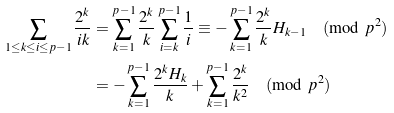<formula> <loc_0><loc_0><loc_500><loc_500>\sum _ { 1 \leq k \leq i \leq p - 1 } \frac { 2 ^ { k } } { i k } & = \sum _ { k = 1 } ^ { p - 1 } \frac { 2 ^ { k } } { k } \sum _ { i = k } ^ { p - 1 } \frac { 1 } { i } \equiv - \sum _ { k = 1 } ^ { p - 1 } \frac { 2 ^ { k } } { k } H _ { k - 1 } \pmod { p ^ { 2 } } \\ & = - \sum _ { k = 1 } ^ { p - 1 } \frac { 2 ^ { k } H _ { k } } { k } + \sum _ { k = 1 } ^ { p - 1 } \frac { 2 ^ { k } } { k ^ { 2 } } \pmod { p ^ { 2 } }</formula> 